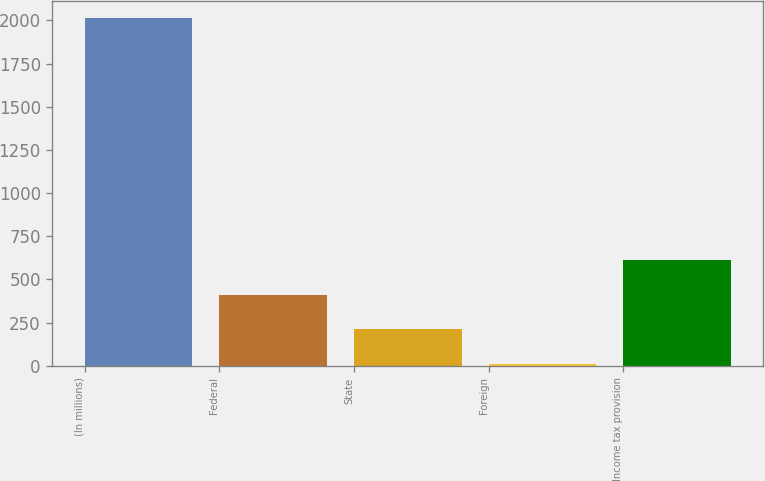<chart> <loc_0><loc_0><loc_500><loc_500><bar_chart><fcel>(In millions)<fcel>Federal<fcel>State<fcel>Foreign<fcel>Income tax provision<nl><fcel>2014<fcel>410.8<fcel>210.4<fcel>10<fcel>611.2<nl></chart> 